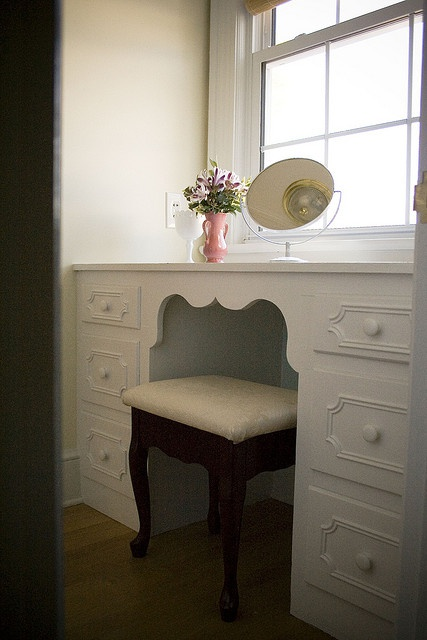Describe the objects in this image and their specific colors. I can see chair in black, tan, and gray tones, vase in black, brown, lightpink, lightgray, and tan tones, and vase in black, lightgray, and darkgray tones in this image. 